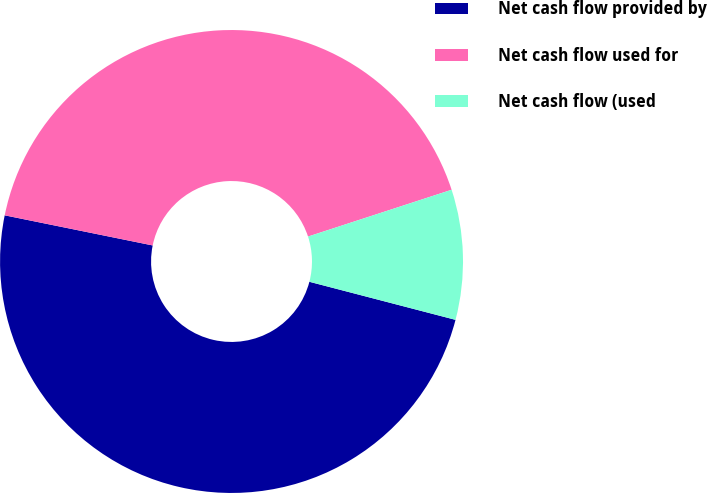<chart> <loc_0><loc_0><loc_500><loc_500><pie_chart><fcel>Net cash flow provided by<fcel>Net cash flow used for<fcel>Net cash flow (used<nl><fcel>49.14%<fcel>41.79%<fcel>9.07%<nl></chart> 